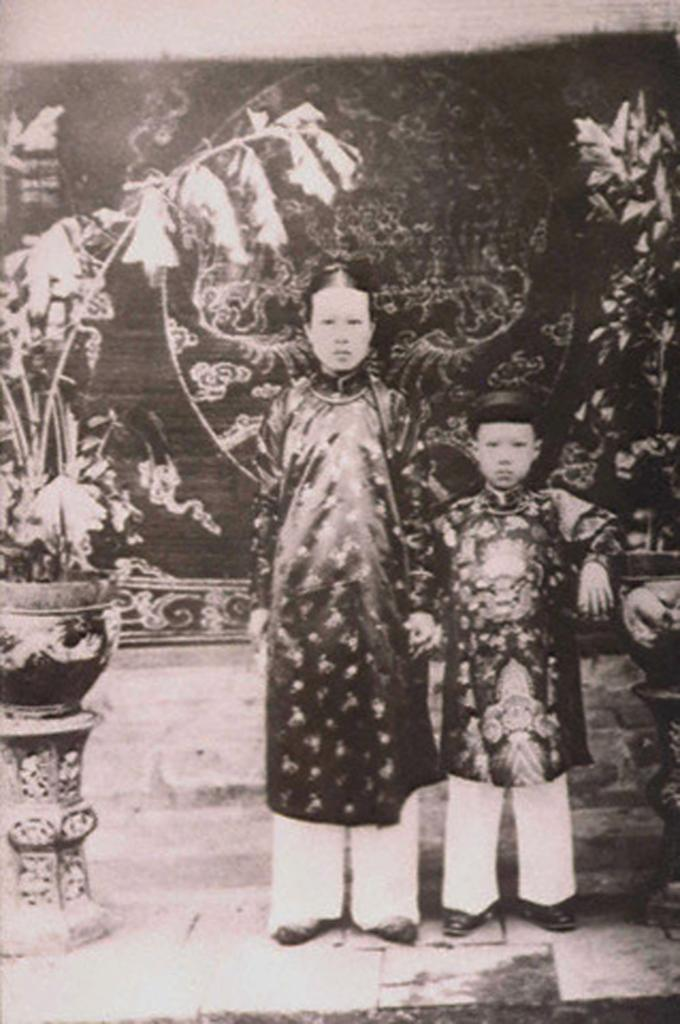What is the color scheme of the image? The image is black and white. How many people are in the image? There are two persons standing in the image. Where are the persons standing? The persons are standing on the ground. What can be seen in the image besides the people? There are potted plants on stands in the image. What is visible in the background of the image? There is a wall visible in the background of the image. What type of ink is being used by the laborer in the image? There is no laborer or ink present in the image; it features two persons standing and potted plants on stands. 